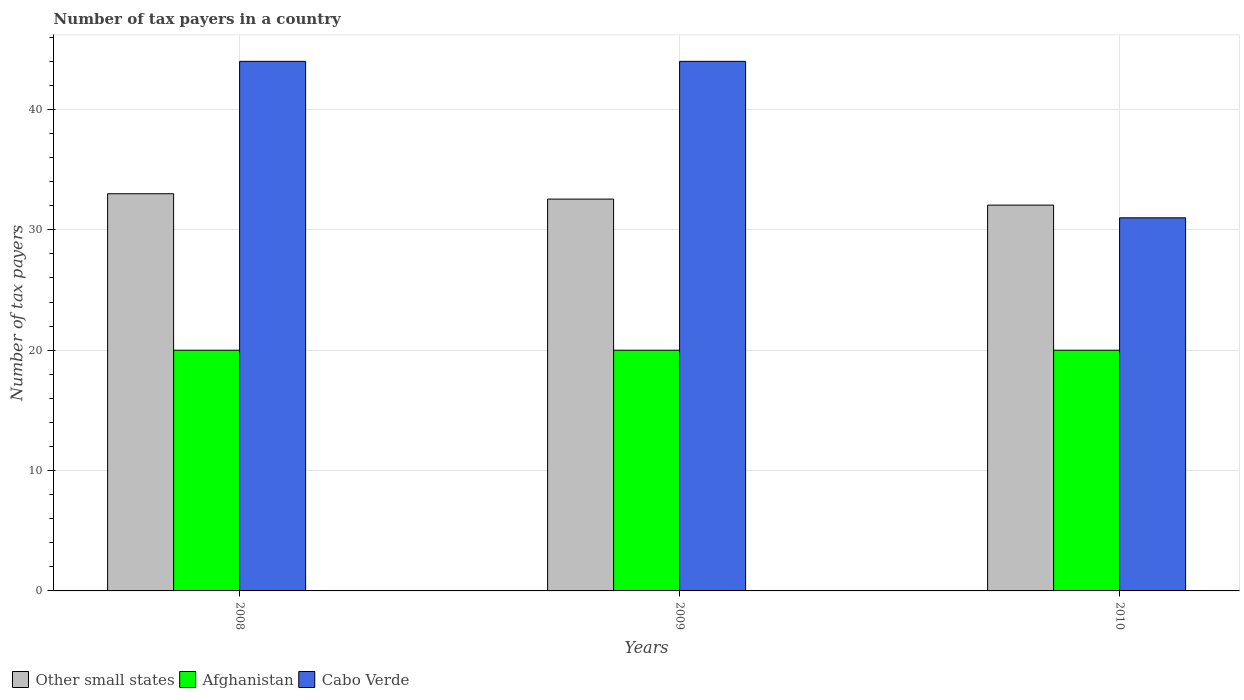Are the number of bars per tick equal to the number of legend labels?
Offer a terse response. Yes. How many bars are there on the 2nd tick from the left?
Your response must be concise. 3. How many bars are there on the 2nd tick from the right?
Your answer should be compact. 3. What is the label of the 2nd group of bars from the left?
Your answer should be compact. 2009. In how many cases, is the number of bars for a given year not equal to the number of legend labels?
Your response must be concise. 0. What is the number of tax payers in in Afghanistan in 2010?
Your answer should be very brief. 20. Across all years, what is the maximum number of tax payers in in Cabo Verde?
Your answer should be very brief. 44. Across all years, what is the minimum number of tax payers in in Other small states?
Your answer should be compact. 32.06. What is the total number of tax payers in in Other small states in the graph?
Offer a terse response. 97.61. What is the difference between the number of tax payers in in Cabo Verde in 2008 and that in 2010?
Your answer should be very brief. 13. What is the difference between the number of tax payers in in Cabo Verde in 2008 and the number of tax payers in in Afghanistan in 2010?
Your response must be concise. 24. What is the average number of tax payers in in Cabo Verde per year?
Your answer should be very brief. 39.67. In the year 2009, what is the difference between the number of tax payers in in Cabo Verde and number of tax payers in in Afghanistan?
Give a very brief answer. 24. In how many years, is the number of tax payers in in Other small states greater than 16?
Provide a succinct answer. 3. Is the difference between the number of tax payers in in Cabo Verde in 2009 and 2010 greater than the difference between the number of tax payers in in Afghanistan in 2009 and 2010?
Your response must be concise. Yes. What is the difference between the highest and the lowest number of tax payers in in Afghanistan?
Make the answer very short. 0. What does the 1st bar from the left in 2009 represents?
Offer a very short reply. Other small states. What does the 2nd bar from the right in 2009 represents?
Keep it short and to the point. Afghanistan. Is it the case that in every year, the sum of the number of tax payers in in Other small states and number of tax payers in in Cabo Verde is greater than the number of tax payers in in Afghanistan?
Ensure brevity in your answer.  Yes. Where does the legend appear in the graph?
Ensure brevity in your answer.  Bottom left. What is the title of the graph?
Make the answer very short. Number of tax payers in a country. Does "Nepal" appear as one of the legend labels in the graph?
Your answer should be compact. No. What is the label or title of the X-axis?
Offer a very short reply. Years. What is the label or title of the Y-axis?
Keep it short and to the point. Number of tax payers. What is the Number of tax payers in Afghanistan in 2008?
Your response must be concise. 20. What is the Number of tax payers in Other small states in 2009?
Provide a succinct answer. 32.56. What is the Number of tax payers of Other small states in 2010?
Provide a short and direct response. 32.06. What is the Number of tax payers in Afghanistan in 2010?
Your answer should be very brief. 20. What is the Number of tax payers of Cabo Verde in 2010?
Give a very brief answer. 31. Across all years, what is the maximum Number of tax payers of Afghanistan?
Offer a very short reply. 20. Across all years, what is the minimum Number of tax payers in Other small states?
Offer a very short reply. 32.06. Across all years, what is the minimum Number of tax payers of Cabo Verde?
Provide a succinct answer. 31. What is the total Number of tax payers of Other small states in the graph?
Ensure brevity in your answer.  97.61. What is the total Number of tax payers of Afghanistan in the graph?
Provide a short and direct response. 60. What is the total Number of tax payers in Cabo Verde in the graph?
Your answer should be compact. 119. What is the difference between the Number of tax payers of Other small states in 2008 and that in 2009?
Provide a succinct answer. 0.44. What is the difference between the Number of tax payers of Other small states in 2008 and that in 2010?
Offer a very short reply. 0.94. What is the difference between the Number of tax payers in Afghanistan in 2008 and that in 2010?
Provide a short and direct response. 0. What is the difference between the Number of tax payers in Cabo Verde in 2008 and that in 2010?
Keep it short and to the point. 13. What is the difference between the Number of tax payers of Other small states in 2009 and that in 2010?
Your answer should be compact. 0.5. What is the difference between the Number of tax payers of Cabo Verde in 2009 and that in 2010?
Provide a succinct answer. 13. What is the difference between the Number of tax payers in Other small states in 2008 and the Number of tax payers in Afghanistan in 2009?
Your answer should be very brief. 13. What is the difference between the Number of tax payers in Other small states in 2008 and the Number of tax payers in Cabo Verde in 2009?
Your answer should be very brief. -11. What is the difference between the Number of tax payers of Other small states in 2008 and the Number of tax payers of Afghanistan in 2010?
Provide a short and direct response. 13. What is the difference between the Number of tax payers in Other small states in 2008 and the Number of tax payers in Cabo Verde in 2010?
Keep it short and to the point. 2. What is the difference between the Number of tax payers in Afghanistan in 2008 and the Number of tax payers in Cabo Verde in 2010?
Your answer should be compact. -11. What is the difference between the Number of tax payers of Other small states in 2009 and the Number of tax payers of Afghanistan in 2010?
Provide a succinct answer. 12.56. What is the difference between the Number of tax payers in Other small states in 2009 and the Number of tax payers in Cabo Verde in 2010?
Give a very brief answer. 1.56. What is the average Number of tax payers of Other small states per year?
Offer a very short reply. 32.54. What is the average Number of tax payers in Cabo Verde per year?
Give a very brief answer. 39.67. In the year 2008, what is the difference between the Number of tax payers of Other small states and Number of tax payers of Cabo Verde?
Offer a very short reply. -11. In the year 2009, what is the difference between the Number of tax payers in Other small states and Number of tax payers in Afghanistan?
Your response must be concise. 12.56. In the year 2009, what is the difference between the Number of tax payers of Other small states and Number of tax payers of Cabo Verde?
Ensure brevity in your answer.  -11.44. In the year 2010, what is the difference between the Number of tax payers in Other small states and Number of tax payers in Afghanistan?
Offer a terse response. 12.06. In the year 2010, what is the difference between the Number of tax payers in Other small states and Number of tax payers in Cabo Verde?
Your answer should be compact. 1.06. What is the ratio of the Number of tax payers of Other small states in 2008 to that in 2009?
Make the answer very short. 1.01. What is the ratio of the Number of tax payers in Other small states in 2008 to that in 2010?
Keep it short and to the point. 1.03. What is the ratio of the Number of tax payers in Afghanistan in 2008 to that in 2010?
Offer a terse response. 1. What is the ratio of the Number of tax payers of Cabo Verde in 2008 to that in 2010?
Offer a very short reply. 1.42. What is the ratio of the Number of tax payers of Other small states in 2009 to that in 2010?
Provide a short and direct response. 1.02. What is the ratio of the Number of tax payers of Cabo Verde in 2009 to that in 2010?
Keep it short and to the point. 1.42. What is the difference between the highest and the second highest Number of tax payers in Other small states?
Your answer should be compact. 0.44. What is the difference between the highest and the second highest Number of tax payers of Afghanistan?
Offer a terse response. 0. What is the difference between the highest and the lowest Number of tax payers in Other small states?
Your response must be concise. 0.94. What is the difference between the highest and the lowest Number of tax payers of Cabo Verde?
Your answer should be very brief. 13. 